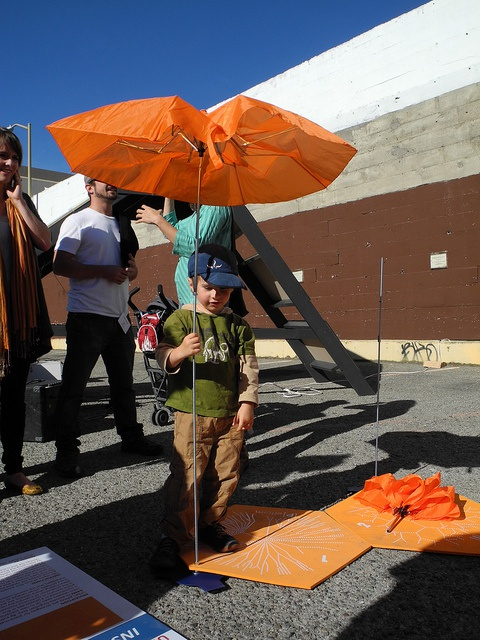Describe the objects in this image and their specific colors. I can see umbrella in darkblue, red, brown, maroon, and orange tones, people in darkblue, black, olive, maroon, and tan tones, people in darkblue, black, gray, navy, and lightgray tones, people in darkblue, black, maroon, brown, and gray tones, and people in darkblue, black, turquoise, and gray tones in this image. 